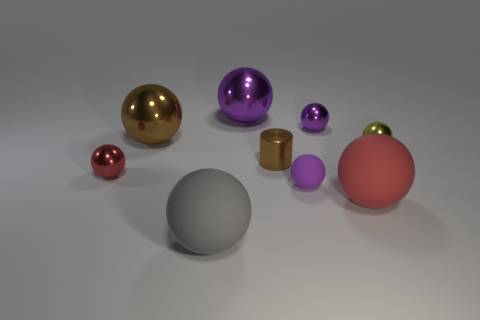Subtract all large gray balls. How many balls are left? 7 Add 1 tiny blue metallic things. How many objects exist? 10 Subtract all brown balls. How many balls are left? 7 Subtract all cylinders. How many objects are left? 8 Subtract 1 cylinders. How many cylinders are left? 0 Subtract all purple spheres. Subtract all brown cylinders. How many spheres are left? 5 Subtract all purple cylinders. How many green balls are left? 0 Subtract all small yellow metallic things. Subtract all large metal cylinders. How many objects are left? 8 Add 6 tiny brown things. How many tiny brown things are left? 7 Add 6 large blue things. How many large blue things exist? 6 